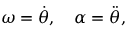Convert formula to latex. <formula><loc_0><loc_0><loc_500><loc_500>\omega = { \dot { \theta } } , \quad \alpha = { \ddot { \theta } } ,</formula> 